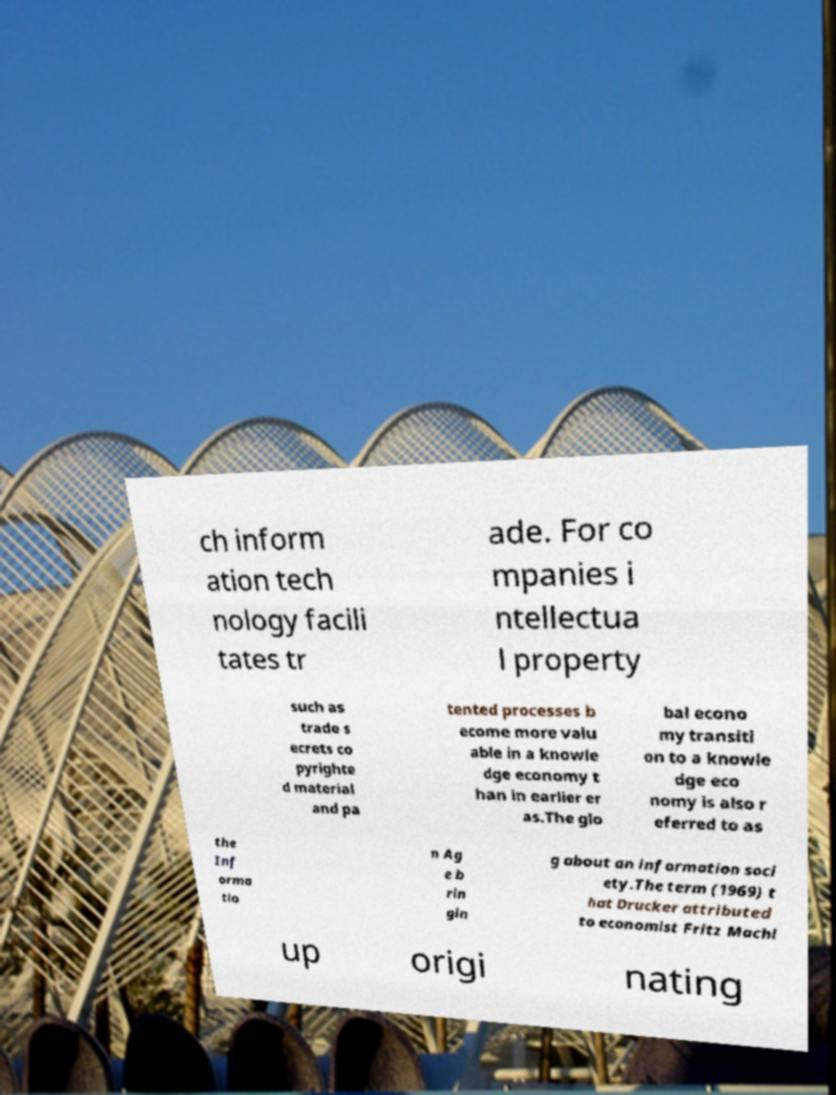I need the written content from this picture converted into text. Can you do that? ch inform ation tech nology facili tates tr ade. For co mpanies i ntellectua l property such as trade s ecrets co pyrighte d material and pa tented processes b ecome more valu able in a knowle dge economy t han in earlier er as.The glo bal econo my transiti on to a knowle dge eco nomy is also r eferred to as the Inf orma tio n Ag e b rin gin g about an information soci ety.The term (1969) t hat Drucker attributed to economist Fritz Machl up origi nating 